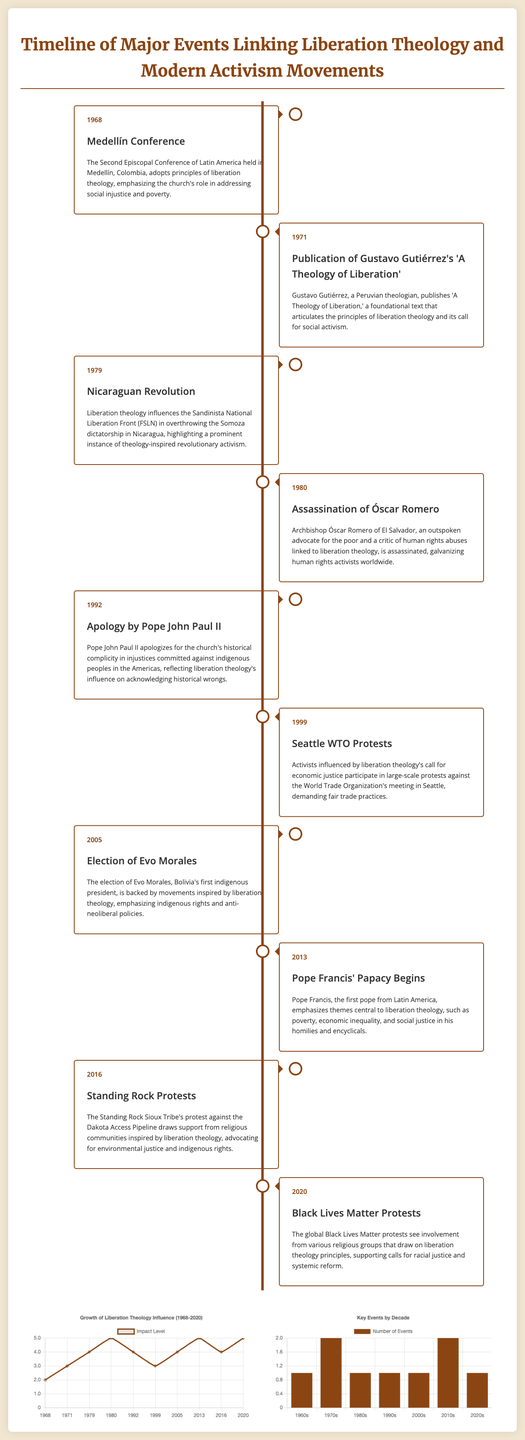What year was the Medellín Conference held? The Medellín Conference took place in 1968, as indicated in the timeline section of the document.
Answer: 1968 Who published 'A Theology of Liberation'? The author of 'A Theology of Liberation' is Gustavo Gutiérrez, as mentioned in the event description from 1971.
Answer: Gustavo Gutiérrez What influential event occurred in 1980? The assassination of Óscar Romero is the significant event from 1980 highlighted in the timeline.
Answer: Assassination of Óscar Romero What was the impact level in 1999? The impact level in 1999, according to the line chart in the document, was 3.
Answer: 3 Which decade had the highest number of events? The 2010s had the highest number of events with 2 instances noted in the bar chart section.
Answer: 2010s What theme did Pope Francis emphasize during his papacy? Pope Francis emphasized themes central to liberation theology, specifically poverty and economic inequality.
Answer: Poverty and economic inequality In what year did the Black Lives Matter protests occur? The Black Lives Matter protests took place in 2020, as shown in the timeline.
Answer: 2020 What was the title of the foundational text published in 1971? The foundational text published in 1971 is titled 'A Theology of Liberation'.
Answer: A Theology of Liberation How many events are listed in the 1980s? The document indicates there is 1 event listed in the 1980s timeline.
Answer: 1 What is the maximum impact level indicated on the line chart? The maximum impact level indicated on the line chart is 5.
Answer: 5 